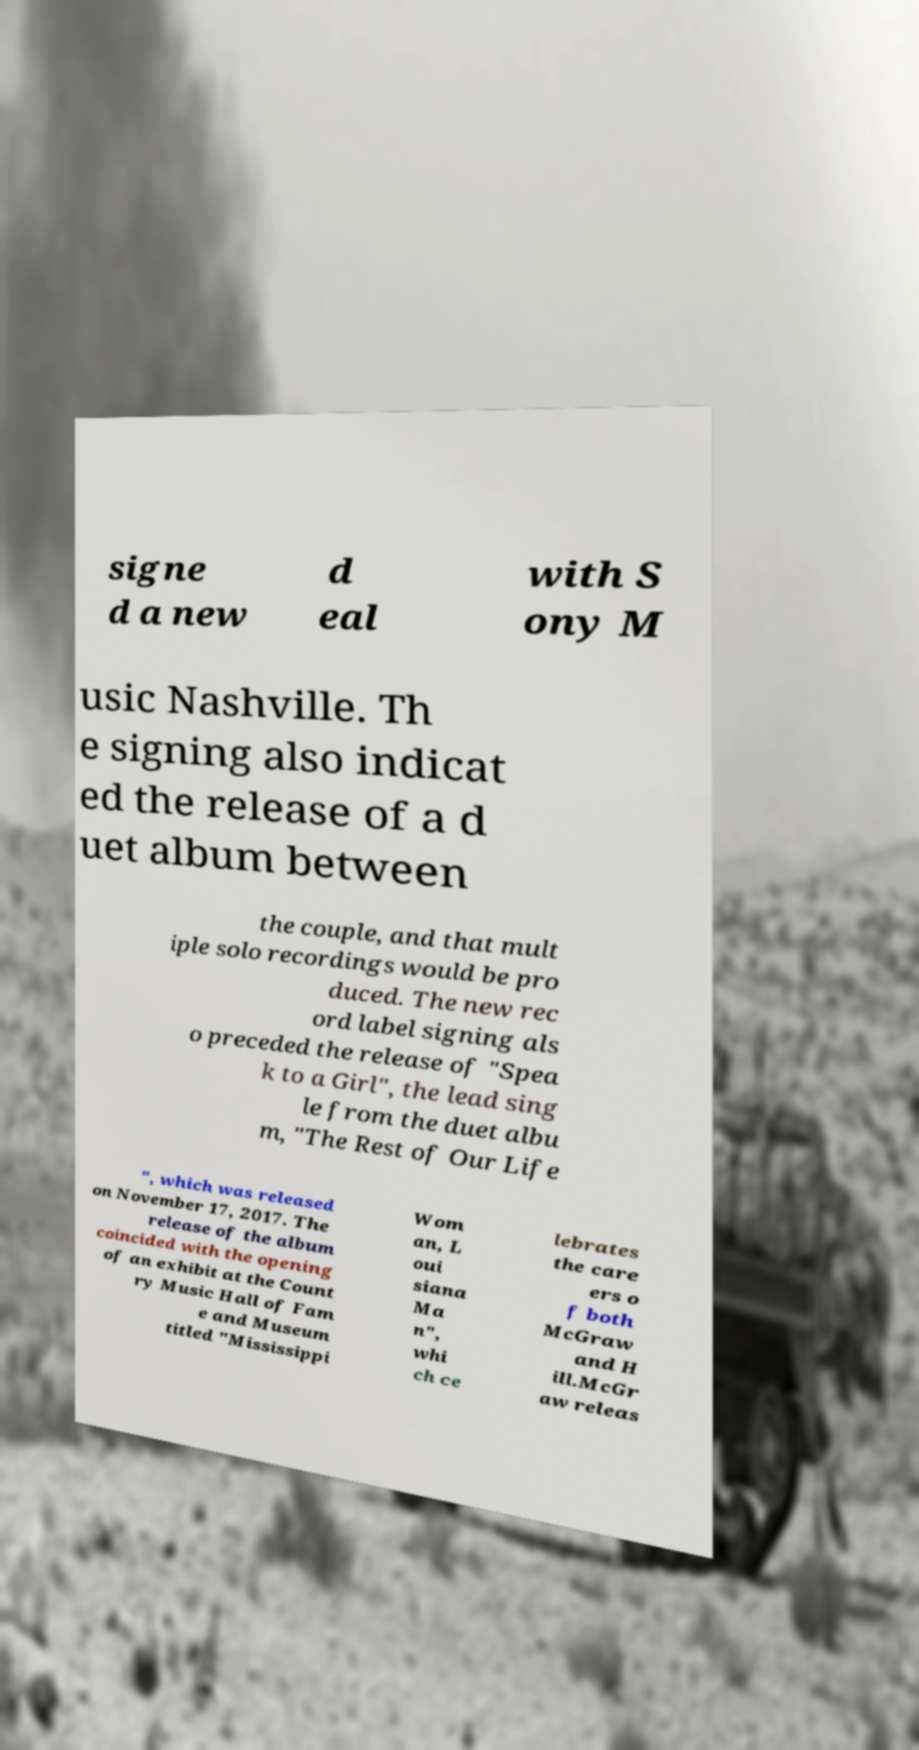What messages or text are displayed in this image? I need them in a readable, typed format. signe d a new d eal with S ony M usic Nashville. Th e signing also indicat ed the release of a d uet album between the couple, and that mult iple solo recordings would be pro duced. The new rec ord label signing als o preceded the release of "Spea k to a Girl", the lead sing le from the duet albu m, "The Rest of Our Life ", which was released on November 17, 2017. The release of the album coincided with the opening of an exhibit at the Count ry Music Hall of Fam e and Museum titled "Mississippi Wom an, L oui siana Ma n", whi ch ce lebrates the care ers o f both McGraw and H ill.McGr aw releas 